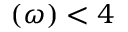<formula> <loc_0><loc_0><loc_500><loc_500>( \omega ) < 4</formula> 